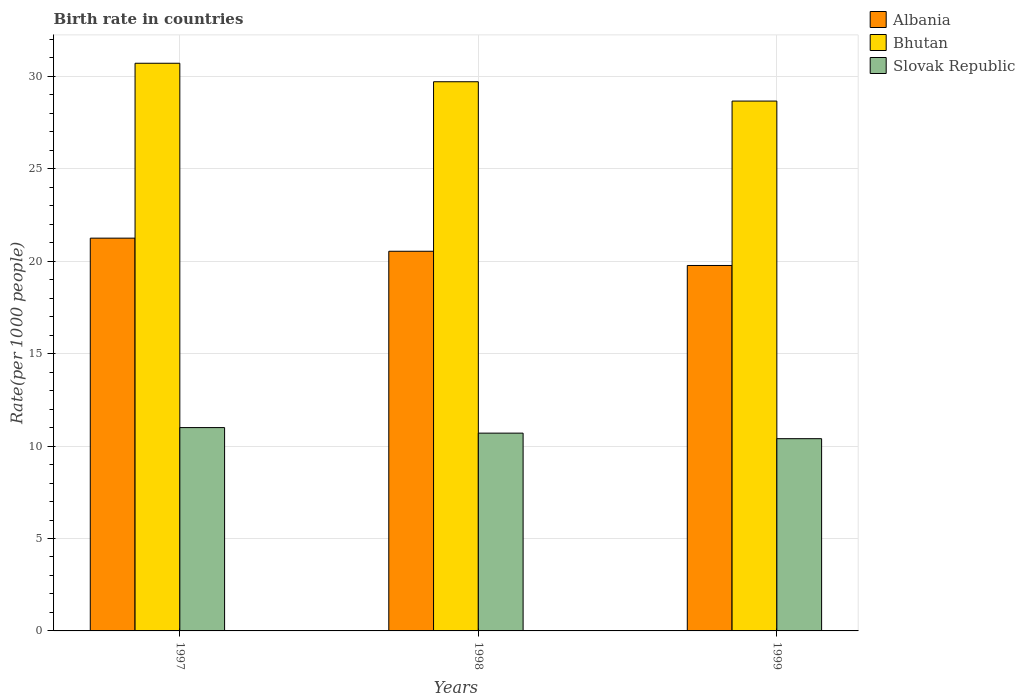How many different coloured bars are there?
Make the answer very short. 3. Are the number of bars on each tick of the X-axis equal?
Give a very brief answer. Yes. How many bars are there on the 2nd tick from the right?
Offer a very short reply. 3. What is the label of the 3rd group of bars from the left?
Offer a terse response. 1999. In how many cases, is the number of bars for a given year not equal to the number of legend labels?
Make the answer very short. 0. What is the birth rate in Albania in 1999?
Provide a succinct answer. 19.77. Across all years, what is the maximum birth rate in Slovak Republic?
Provide a succinct answer. 11. Across all years, what is the minimum birth rate in Albania?
Your answer should be compact. 19.77. What is the total birth rate in Slovak Republic in the graph?
Provide a short and direct response. 32.1. What is the difference between the birth rate in Slovak Republic in 1998 and that in 1999?
Offer a terse response. 0.3. What is the difference between the birth rate in Bhutan in 1998 and the birth rate in Slovak Republic in 1999?
Ensure brevity in your answer.  19.31. What is the average birth rate in Bhutan per year?
Give a very brief answer. 29.69. In the year 1997, what is the difference between the birth rate in Albania and birth rate in Bhutan?
Provide a succinct answer. -9.46. In how many years, is the birth rate in Albania greater than 6?
Provide a succinct answer. 3. What is the ratio of the birth rate in Slovak Republic in 1997 to that in 1998?
Your response must be concise. 1.03. Is the birth rate in Albania in 1998 less than that in 1999?
Give a very brief answer. No. Is the difference between the birth rate in Albania in 1997 and 1998 greater than the difference between the birth rate in Bhutan in 1997 and 1998?
Give a very brief answer. No. What is the difference between the highest and the second highest birth rate in Slovak Republic?
Ensure brevity in your answer.  0.3. What is the difference between the highest and the lowest birth rate in Albania?
Provide a succinct answer. 1.48. In how many years, is the birth rate in Bhutan greater than the average birth rate in Bhutan taken over all years?
Make the answer very short. 2. Is the sum of the birth rate in Albania in 1998 and 1999 greater than the maximum birth rate in Slovak Republic across all years?
Your response must be concise. Yes. What does the 1st bar from the left in 1999 represents?
Make the answer very short. Albania. What does the 3rd bar from the right in 1997 represents?
Your answer should be very brief. Albania. What is the difference between two consecutive major ticks on the Y-axis?
Your answer should be very brief. 5. Are the values on the major ticks of Y-axis written in scientific E-notation?
Keep it short and to the point. No. Does the graph contain any zero values?
Offer a terse response. No. Does the graph contain grids?
Provide a succinct answer. Yes. Where does the legend appear in the graph?
Your answer should be very brief. Top right. How many legend labels are there?
Your answer should be very brief. 3. What is the title of the graph?
Your answer should be very brief. Birth rate in countries. Does "Tuvalu" appear as one of the legend labels in the graph?
Your answer should be very brief. No. What is the label or title of the Y-axis?
Your answer should be very brief. Rate(per 1000 people). What is the Rate(per 1000 people) in Albania in 1997?
Offer a terse response. 21.25. What is the Rate(per 1000 people) of Bhutan in 1997?
Make the answer very short. 30.71. What is the Rate(per 1000 people) of Albania in 1998?
Provide a succinct answer. 20.54. What is the Rate(per 1000 people) of Bhutan in 1998?
Your response must be concise. 29.71. What is the Rate(per 1000 people) of Slovak Republic in 1998?
Ensure brevity in your answer.  10.7. What is the Rate(per 1000 people) in Albania in 1999?
Provide a short and direct response. 19.77. What is the Rate(per 1000 people) of Bhutan in 1999?
Keep it short and to the point. 28.66. What is the Rate(per 1000 people) of Slovak Republic in 1999?
Your answer should be very brief. 10.4. Across all years, what is the maximum Rate(per 1000 people) in Albania?
Offer a terse response. 21.25. Across all years, what is the maximum Rate(per 1000 people) in Bhutan?
Ensure brevity in your answer.  30.71. Across all years, what is the maximum Rate(per 1000 people) in Slovak Republic?
Offer a very short reply. 11. Across all years, what is the minimum Rate(per 1000 people) in Albania?
Your response must be concise. 19.77. Across all years, what is the minimum Rate(per 1000 people) in Bhutan?
Offer a very short reply. 28.66. Across all years, what is the minimum Rate(per 1000 people) in Slovak Republic?
Provide a short and direct response. 10.4. What is the total Rate(per 1000 people) in Albania in the graph?
Offer a very short reply. 61.56. What is the total Rate(per 1000 people) of Bhutan in the graph?
Provide a short and direct response. 89.08. What is the total Rate(per 1000 people) of Slovak Republic in the graph?
Your response must be concise. 32.1. What is the difference between the Rate(per 1000 people) of Albania in 1997 and that in 1998?
Keep it short and to the point. 0.71. What is the difference between the Rate(per 1000 people) of Bhutan in 1997 and that in 1998?
Your answer should be compact. 1. What is the difference between the Rate(per 1000 people) in Albania in 1997 and that in 1999?
Your answer should be very brief. 1.48. What is the difference between the Rate(per 1000 people) of Bhutan in 1997 and that in 1999?
Your response must be concise. 2.05. What is the difference between the Rate(per 1000 people) of Albania in 1998 and that in 1999?
Ensure brevity in your answer.  0.77. What is the difference between the Rate(per 1000 people) of Bhutan in 1998 and that in 1999?
Your response must be concise. 1.05. What is the difference between the Rate(per 1000 people) of Slovak Republic in 1998 and that in 1999?
Your response must be concise. 0.3. What is the difference between the Rate(per 1000 people) in Albania in 1997 and the Rate(per 1000 people) in Bhutan in 1998?
Provide a short and direct response. -8.46. What is the difference between the Rate(per 1000 people) of Albania in 1997 and the Rate(per 1000 people) of Slovak Republic in 1998?
Provide a short and direct response. 10.55. What is the difference between the Rate(per 1000 people) in Bhutan in 1997 and the Rate(per 1000 people) in Slovak Republic in 1998?
Make the answer very short. 20.01. What is the difference between the Rate(per 1000 people) of Albania in 1997 and the Rate(per 1000 people) of Bhutan in 1999?
Offer a terse response. -7.42. What is the difference between the Rate(per 1000 people) in Albania in 1997 and the Rate(per 1000 people) in Slovak Republic in 1999?
Make the answer very short. 10.85. What is the difference between the Rate(per 1000 people) in Bhutan in 1997 and the Rate(per 1000 people) in Slovak Republic in 1999?
Give a very brief answer. 20.31. What is the difference between the Rate(per 1000 people) in Albania in 1998 and the Rate(per 1000 people) in Bhutan in 1999?
Your response must be concise. -8.12. What is the difference between the Rate(per 1000 people) of Albania in 1998 and the Rate(per 1000 people) of Slovak Republic in 1999?
Make the answer very short. 10.14. What is the difference between the Rate(per 1000 people) in Bhutan in 1998 and the Rate(per 1000 people) in Slovak Republic in 1999?
Ensure brevity in your answer.  19.31. What is the average Rate(per 1000 people) in Albania per year?
Give a very brief answer. 20.52. What is the average Rate(per 1000 people) of Bhutan per year?
Your response must be concise. 29.69. In the year 1997, what is the difference between the Rate(per 1000 people) of Albania and Rate(per 1000 people) of Bhutan?
Provide a succinct answer. -9.46. In the year 1997, what is the difference between the Rate(per 1000 people) in Albania and Rate(per 1000 people) in Slovak Republic?
Keep it short and to the point. 10.25. In the year 1997, what is the difference between the Rate(per 1000 people) of Bhutan and Rate(per 1000 people) of Slovak Republic?
Your answer should be compact. 19.71. In the year 1998, what is the difference between the Rate(per 1000 people) of Albania and Rate(per 1000 people) of Bhutan?
Keep it short and to the point. -9.17. In the year 1998, what is the difference between the Rate(per 1000 people) in Albania and Rate(per 1000 people) in Slovak Republic?
Provide a succinct answer. 9.84. In the year 1998, what is the difference between the Rate(per 1000 people) of Bhutan and Rate(per 1000 people) of Slovak Republic?
Give a very brief answer. 19.01. In the year 1999, what is the difference between the Rate(per 1000 people) in Albania and Rate(per 1000 people) in Bhutan?
Ensure brevity in your answer.  -8.89. In the year 1999, what is the difference between the Rate(per 1000 people) of Albania and Rate(per 1000 people) of Slovak Republic?
Keep it short and to the point. 9.37. In the year 1999, what is the difference between the Rate(per 1000 people) in Bhutan and Rate(per 1000 people) in Slovak Republic?
Provide a short and direct response. 18.26. What is the ratio of the Rate(per 1000 people) in Albania in 1997 to that in 1998?
Offer a terse response. 1.03. What is the ratio of the Rate(per 1000 people) in Bhutan in 1997 to that in 1998?
Ensure brevity in your answer.  1.03. What is the ratio of the Rate(per 1000 people) of Slovak Republic in 1997 to that in 1998?
Your answer should be compact. 1.03. What is the ratio of the Rate(per 1000 people) in Albania in 1997 to that in 1999?
Offer a terse response. 1.07. What is the ratio of the Rate(per 1000 people) in Bhutan in 1997 to that in 1999?
Offer a very short reply. 1.07. What is the ratio of the Rate(per 1000 people) of Slovak Republic in 1997 to that in 1999?
Make the answer very short. 1.06. What is the ratio of the Rate(per 1000 people) in Albania in 1998 to that in 1999?
Make the answer very short. 1.04. What is the ratio of the Rate(per 1000 people) in Bhutan in 1998 to that in 1999?
Make the answer very short. 1.04. What is the ratio of the Rate(per 1000 people) in Slovak Republic in 1998 to that in 1999?
Your answer should be compact. 1.03. What is the difference between the highest and the second highest Rate(per 1000 people) of Albania?
Your answer should be compact. 0.71. What is the difference between the highest and the second highest Rate(per 1000 people) of Slovak Republic?
Make the answer very short. 0.3. What is the difference between the highest and the lowest Rate(per 1000 people) of Albania?
Your answer should be compact. 1.48. What is the difference between the highest and the lowest Rate(per 1000 people) of Bhutan?
Keep it short and to the point. 2.05. What is the difference between the highest and the lowest Rate(per 1000 people) of Slovak Republic?
Make the answer very short. 0.6. 